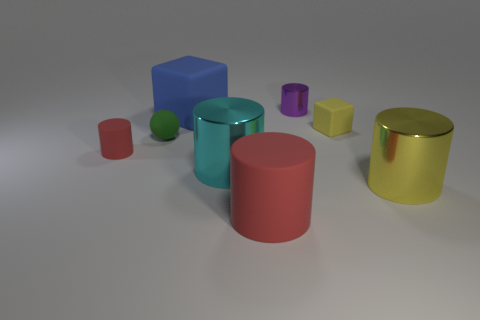Subtract all big yellow shiny cylinders. How many cylinders are left? 4 Add 2 yellow cylinders. How many objects exist? 10 Subtract all red cylinders. How many cylinders are left? 3 Subtract all red spheres. How many red cylinders are left? 2 Subtract 1 spheres. How many spheres are left? 0 Subtract all purple cubes. Subtract all purple cylinders. How many cubes are left? 2 Add 2 small yellow things. How many small yellow things exist? 3 Subtract 0 yellow spheres. How many objects are left? 8 Subtract all balls. How many objects are left? 7 Subtract all tiny green objects. Subtract all large purple metallic balls. How many objects are left? 7 